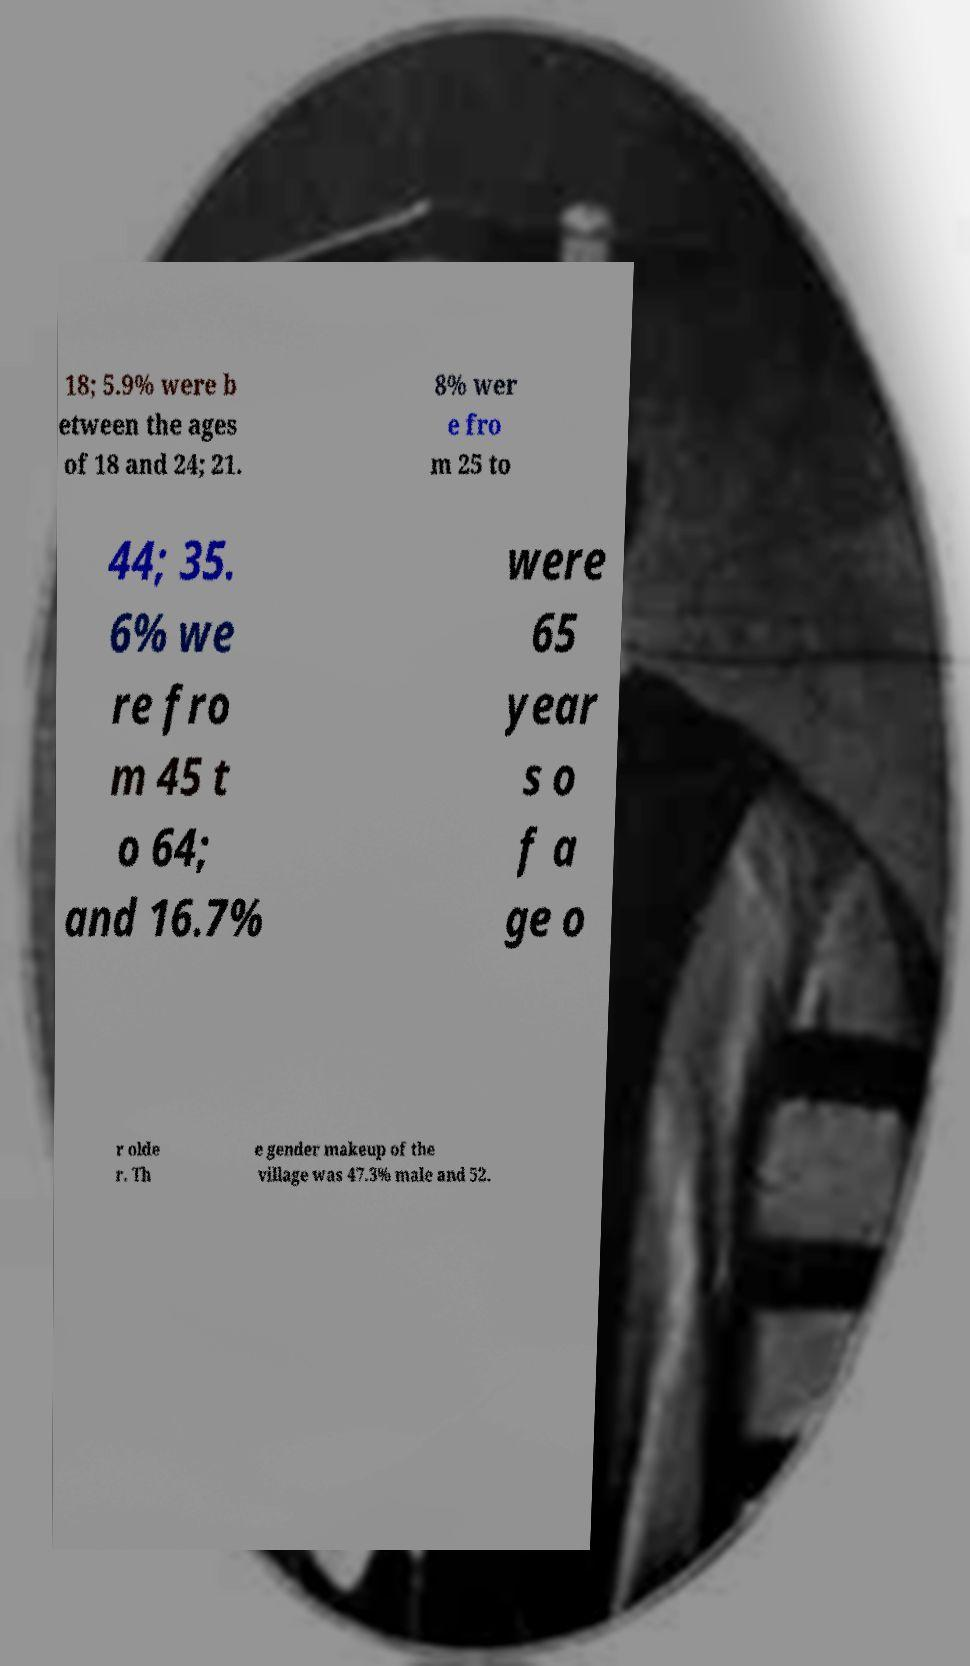What messages or text are displayed in this image? I need them in a readable, typed format. 18; 5.9% were b etween the ages of 18 and 24; 21. 8% wer e fro m 25 to 44; 35. 6% we re fro m 45 t o 64; and 16.7% were 65 year s o f a ge o r olde r. Th e gender makeup of the village was 47.3% male and 52. 